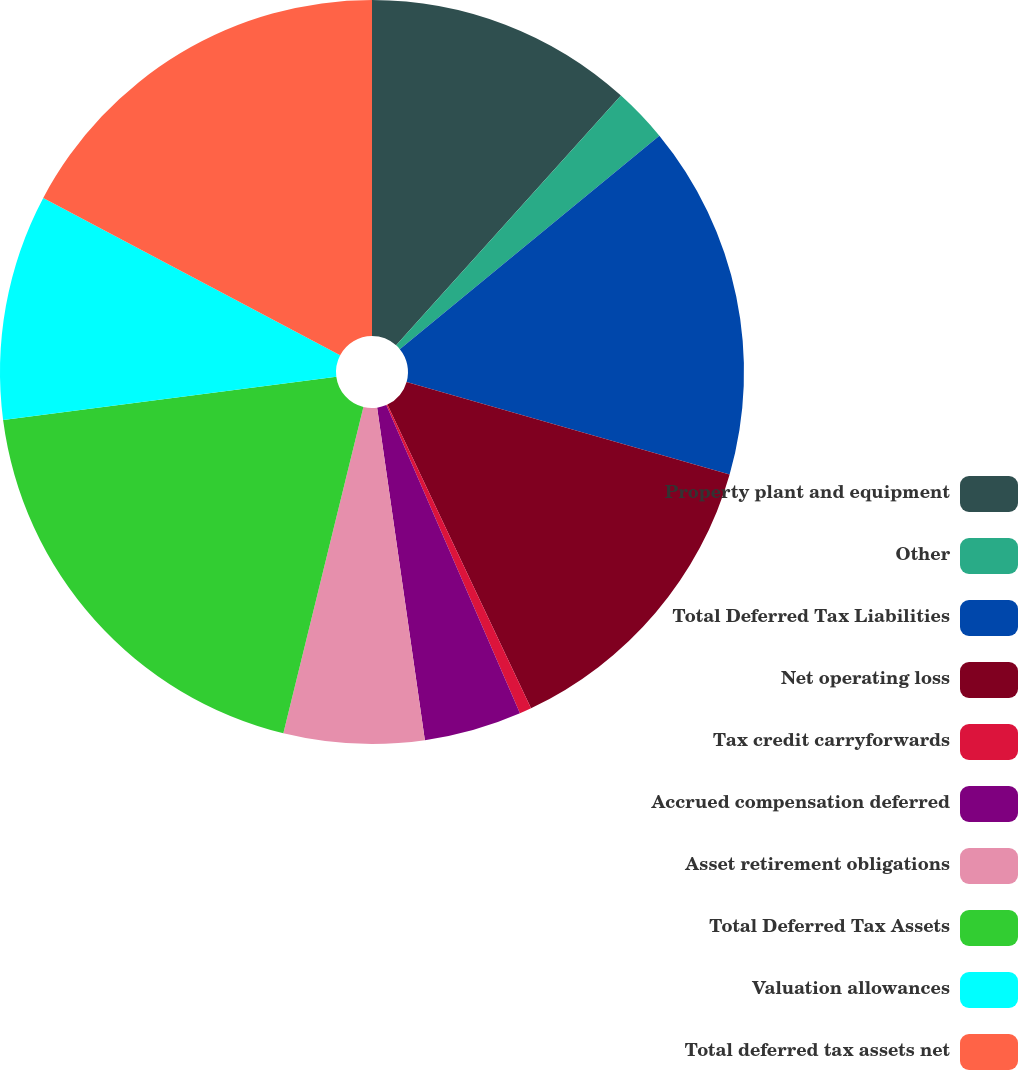<chart> <loc_0><loc_0><loc_500><loc_500><pie_chart><fcel>Property plant and equipment<fcel>Other<fcel>Total Deferred Tax Liabilities<fcel>Net operating loss<fcel>Tax credit carryforwards<fcel>Accrued compensation deferred<fcel>Asset retirement obligations<fcel>Total Deferred Tax Assets<fcel>Valuation allowances<fcel>Total deferred tax assets net<nl><fcel>11.67%<fcel>2.38%<fcel>15.39%<fcel>13.53%<fcel>0.52%<fcel>4.24%<fcel>6.1%<fcel>19.11%<fcel>9.81%<fcel>17.25%<nl></chart> 